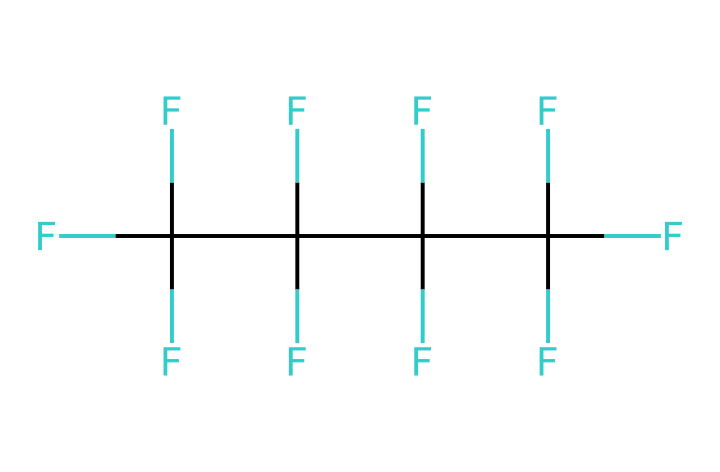What is the total number of fluorine atoms in this chemical? The provided SMILES representation shows multiple 'F' characters denoting fluorine atoms. By counting the 'F's, we identify there are 12 fluorine atoms present.
Answer: 12 How many carbon atoms are in this chemical? The structure also includes 'C' characters representing carbon atoms. By counting these 'C's, we determine there are 4 carbon atoms.
Answer: 4 What type of chemical structure does this represent? The arrangement in the SMILES indicates that this chemical is a fluorocarbon due to the presence of multiple fluorine atoms attached to carbon skeletons.
Answer: fluorocarbon What characteristic property of fluorine contributes to non-stick properties? Fluorine has a high electronegativity and low surface energy, which prevents other substances from adhering to it, making it ideal for non-stick applications.
Answer: low surface energy Given the high number of electron-withdrawing fluorine atoms, what can be inferred about the overall polarity of this compound? With a majority of fluorine atoms, the compound exhibits a high degree of electronegativity which leads to a polar character, even though the carbon backbone contributes some non-polar characteristics.
Answer: polar What is the main application of this type of fluorinated compound in everyday items? This type of compound is primarily used in the production of non-stick coatings for cookware to prevent food from sticking during cooking.
Answer: non-stick cookware 